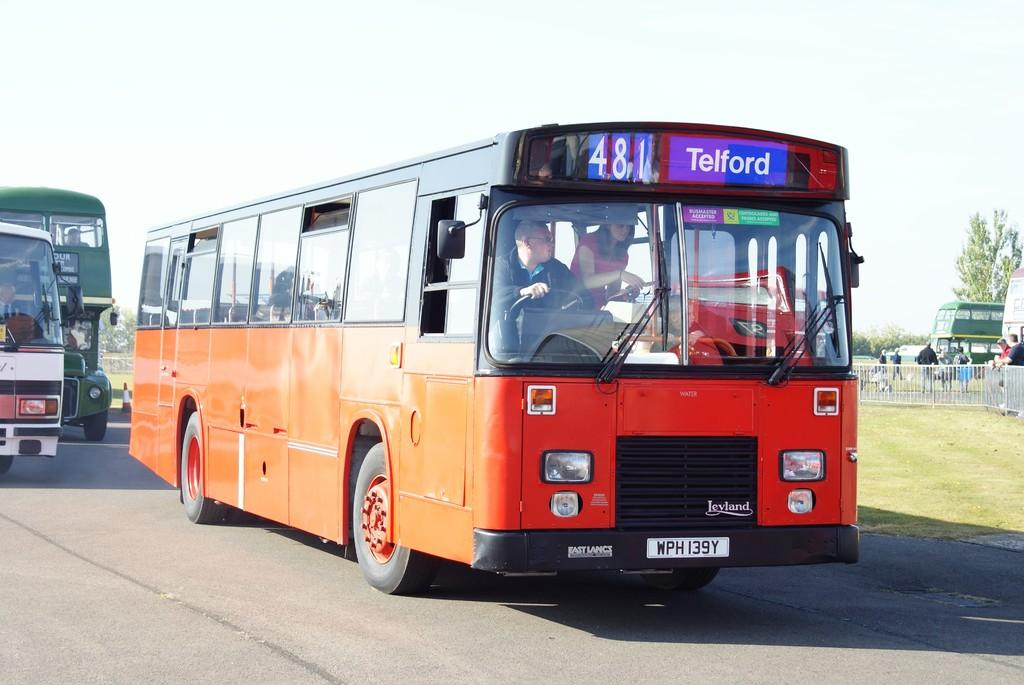<image>
Relay a brief, clear account of the picture shown. A one decker bus that is going to Telford 